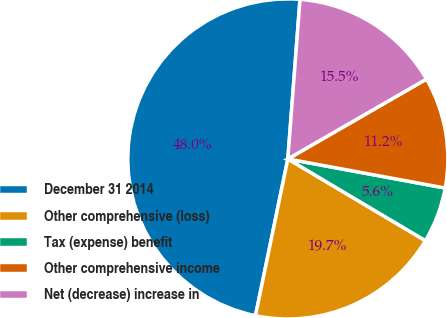Convert chart. <chart><loc_0><loc_0><loc_500><loc_500><pie_chart><fcel>December 31 2014<fcel>Other comprehensive (loss)<fcel>Tax (expense) benefit<fcel>Other comprehensive income<fcel>Net (decrease) increase in<nl><fcel>47.97%<fcel>19.71%<fcel>5.62%<fcel>11.23%<fcel>15.47%<nl></chart> 